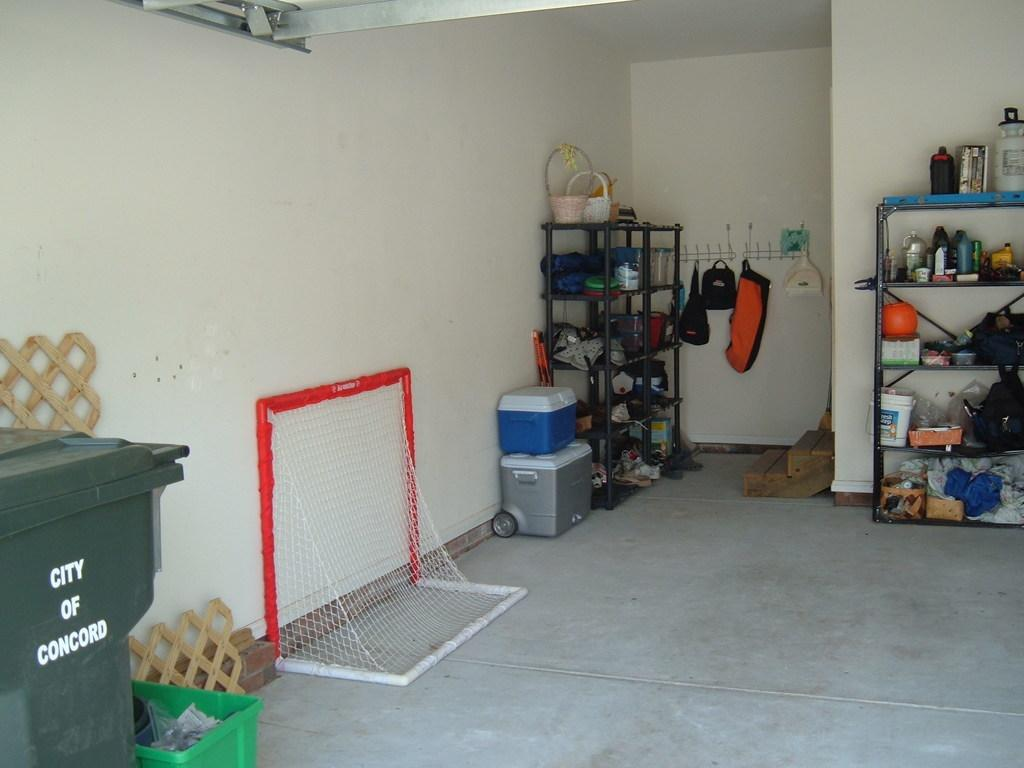<image>
Give a short and clear explanation of the subsequent image. A garbage can from Concord is sitting in the edge of a garage. 